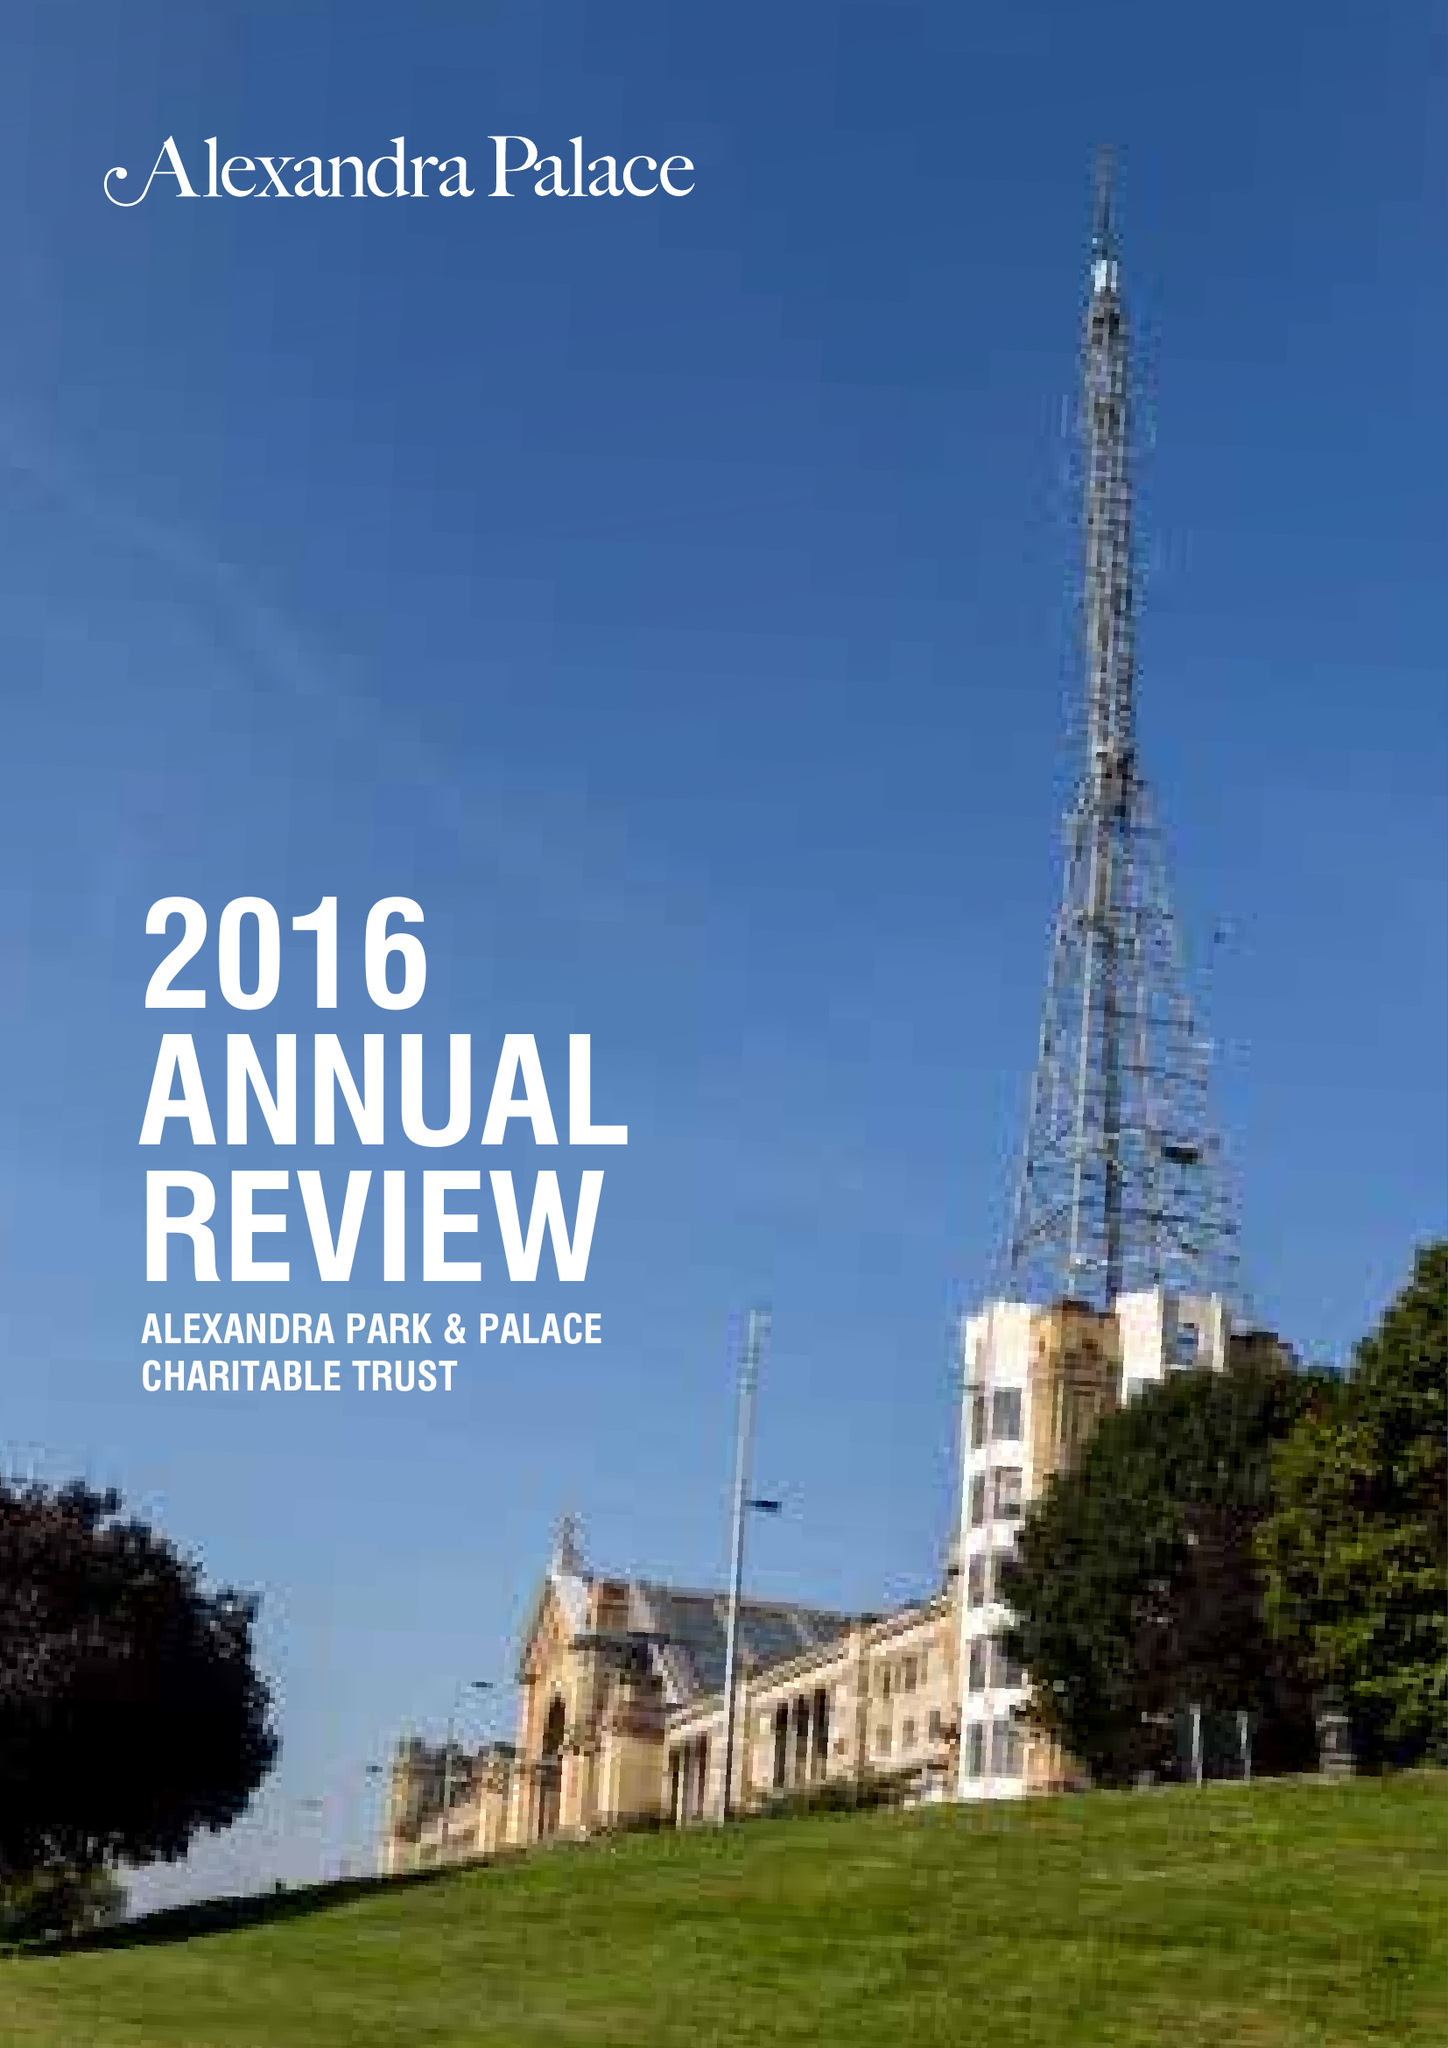What is the value for the charity_number?
Answer the question using a single word or phrase. 281991 